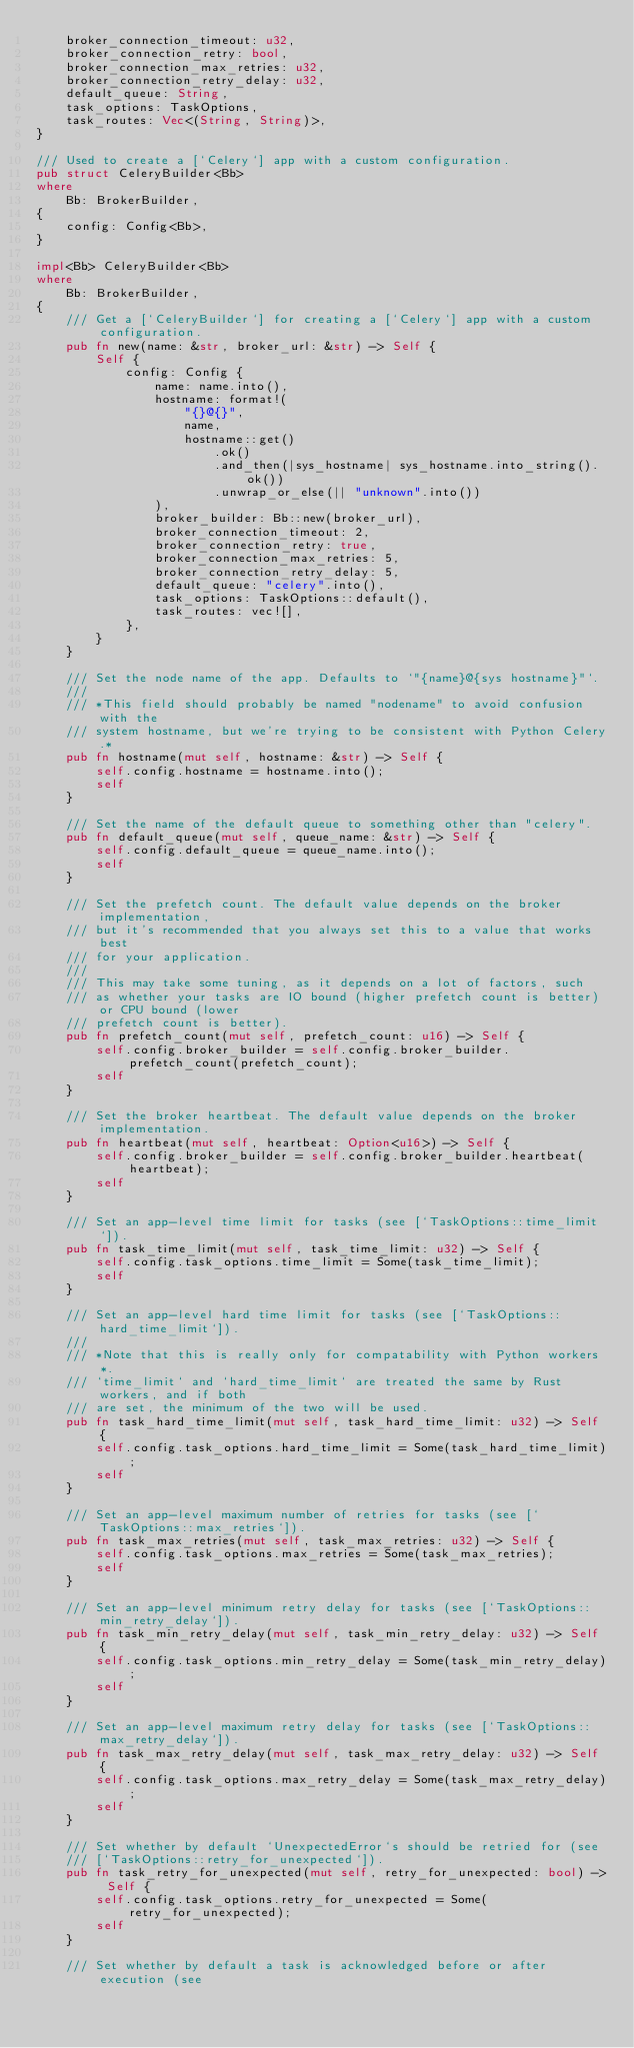Convert code to text. <code><loc_0><loc_0><loc_500><loc_500><_Rust_>    broker_connection_timeout: u32,
    broker_connection_retry: bool,
    broker_connection_max_retries: u32,
    broker_connection_retry_delay: u32,
    default_queue: String,
    task_options: TaskOptions,
    task_routes: Vec<(String, String)>,
}

/// Used to create a [`Celery`] app with a custom configuration.
pub struct CeleryBuilder<Bb>
where
    Bb: BrokerBuilder,
{
    config: Config<Bb>,
}

impl<Bb> CeleryBuilder<Bb>
where
    Bb: BrokerBuilder,
{
    /// Get a [`CeleryBuilder`] for creating a [`Celery`] app with a custom configuration.
    pub fn new(name: &str, broker_url: &str) -> Self {
        Self {
            config: Config {
                name: name.into(),
                hostname: format!(
                    "{}@{}",
                    name,
                    hostname::get()
                        .ok()
                        .and_then(|sys_hostname| sys_hostname.into_string().ok())
                        .unwrap_or_else(|| "unknown".into())
                ),
                broker_builder: Bb::new(broker_url),
                broker_connection_timeout: 2,
                broker_connection_retry: true,
                broker_connection_max_retries: 5,
                broker_connection_retry_delay: 5,
                default_queue: "celery".into(),
                task_options: TaskOptions::default(),
                task_routes: vec![],
            },
        }
    }

    /// Set the node name of the app. Defaults to `"{name}@{sys hostname}"`.
    ///
    /// *This field should probably be named "nodename" to avoid confusion with the
    /// system hostname, but we're trying to be consistent with Python Celery.*
    pub fn hostname(mut self, hostname: &str) -> Self {
        self.config.hostname = hostname.into();
        self
    }

    /// Set the name of the default queue to something other than "celery".
    pub fn default_queue(mut self, queue_name: &str) -> Self {
        self.config.default_queue = queue_name.into();
        self
    }

    /// Set the prefetch count. The default value depends on the broker implementation,
    /// but it's recommended that you always set this to a value that works best
    /// for your application.
    ///
    /// This may take some tuning, as it depends on a lot of factors, such
    /// as whether your tasks are IO bound (higher prefetch count is better) or CPU bound (lower
    /// prefetch count is better).
    pub fn prefetch_count(mut self, prefetch_count: u16) -> Self {
        self.config.broker_builder = self.config.broker_builder.prefetch_count(prefetch_count);
        self
    }

    /// Set the broker heartbeat. The default value depends on the broker implementation.
    pub fn heartbeat(mut self, heartbeat: Option<u16>) -> Self {
        self.config.broker_builder = self.config.broker_builder.heartbeat(heartbeat);
        self
    }

    /// Set an app-level time limit for tasks (see [`TaskOptions::time_limit`]).
    pub fn task_time_limit(mut self, task_time_limit: u32) -> Self {
        self.config.task_options.time_limit = Some(task_time_limit);
        self
    }

    /// Set an app-level hard time limit for tasks (see [`TaskOptions::hard_time_limit`]).
    ///
    /// *Note that this is really only for compatability with Python workers*.
    /// `time_limit` and `hard_time_limit` are treated the same by Rust workers, and if both
    /// are set, the minimum of the two will be used.
    pub fn task_hard_time_limit(mut self, task_hard_time_limit: u32) -> Self {
        self.config.task_options.hard_time_limit = Some(task_hard_time_limit);
        self
    }

    /// Set an app-level maximum number of retries for tasks (see [`TaskOptions::max_retries`]).
    pub fn task_max_retries(mut self, task_max_retries: u32) -> Self {
        self.config.task_options.max_retries = Some(task_max_retries);
        self
    }

    /// Set an app-level minimum retry delay for tasks (see [`TaskOptions::min_retry_delay`]).
    pub fn task_min_retry_delay(mut self, task_min_retry_delay: u32) -> Self {
        self.config.task_options.min_retry_delay = Some(task_min_retry_delay);
        self
    }

    /// Set an app-level maximum retry delay for tasks (see [`TaskOptions::max_retry_delay`]).
    pub fn task_max_retry_delay(mut self, task_max_retry_delay: u32) -> Self {
        self.config.task_options.max_retry_delay = Some(task_max_retry_delay);
        self
    }

    /// Set whether by default `UnexpectedError`s should be retried for (see
    /// [`TaskOptions::retry_for_unexpected`]).
    pub fn task_retry_for_unexpected(mut self, retry_for_unexpected: bool) -> Self {
        self.config.task_options.retry_for_unexpected = Some(retry_for_unexpected);
        self
    }

    /// Set whether by default a task is acknowledged before or after execution (see</code> 